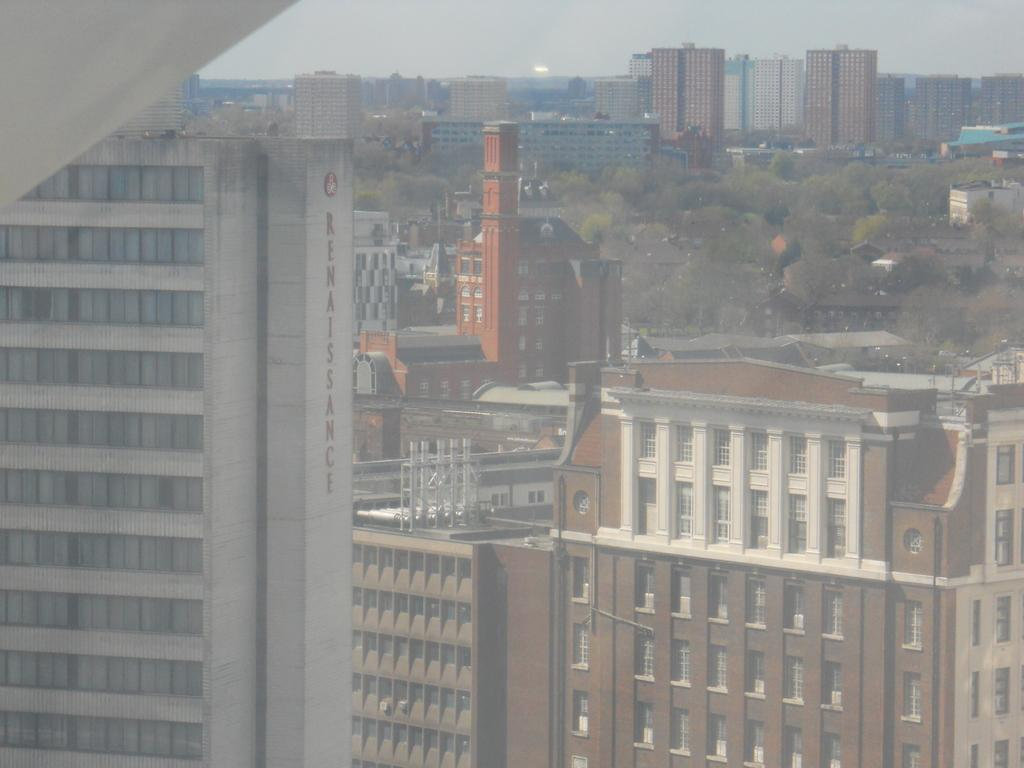What type of structures can be seen in the image? There are buildings in the image. What feature can be observed on the buildings? There are windows visible on the buildings. What type of vegetation is present in the image? There are trees in the image. What is visible in the background of the image? The sky is visible in the background of the image. What type of loaf can be seen in the image? There is no loaf present in the image. 